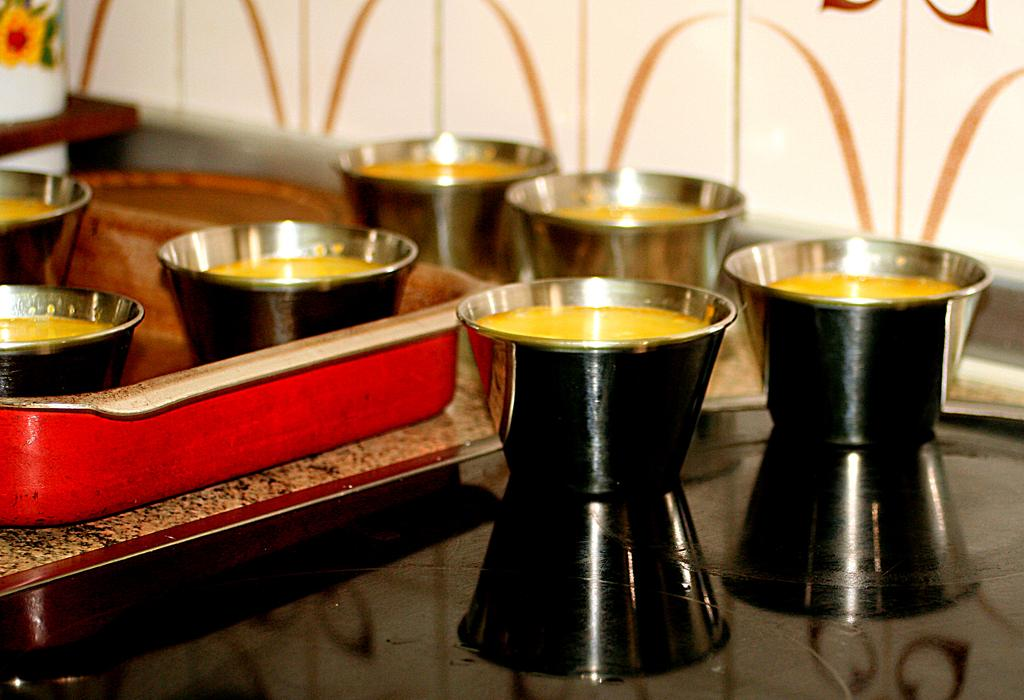What is on the floor in the image? There are bowls on the floor in the image. How are the bowls arranged? The bowls are in a tray. What is inside the bowls? There is food in the bowls. What can be seen at the top of the image? There is a wall at the top of the image. What type of jam is being spread on the flag in the image? There is no jam or flag present in the image; it only features bowls on the floor and a wall at the top. 